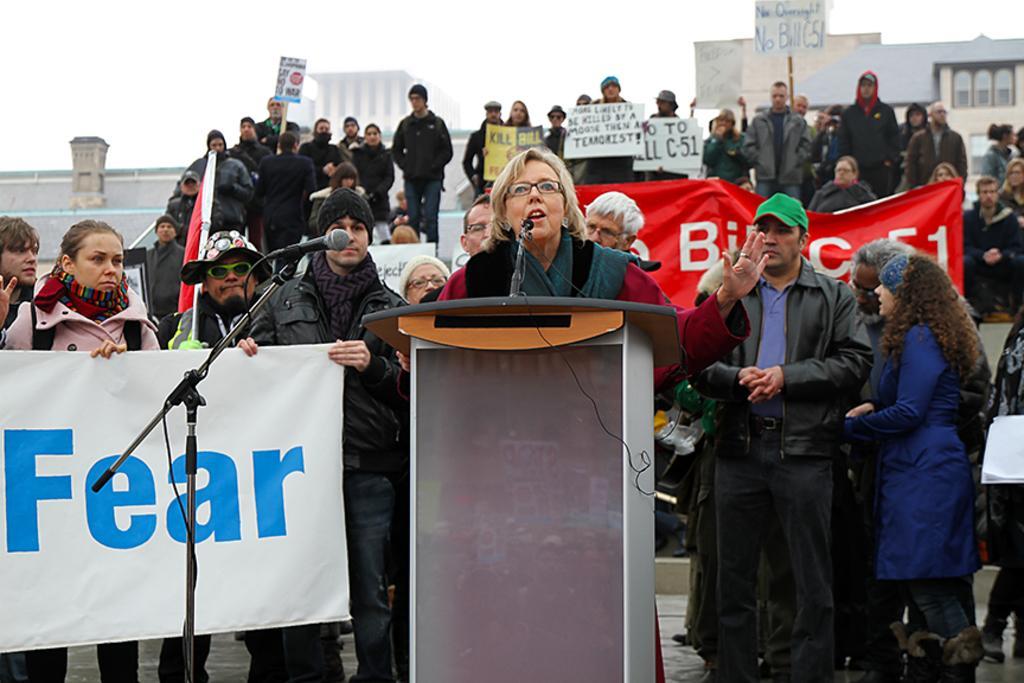Can you describe this image briefly? In the picture I can see people among them some are holding placards and some are holding a banner. Here I can see in front of the image a woman is standing in front of a podium which has a microphone. In the background I can see buildings and the sky. 